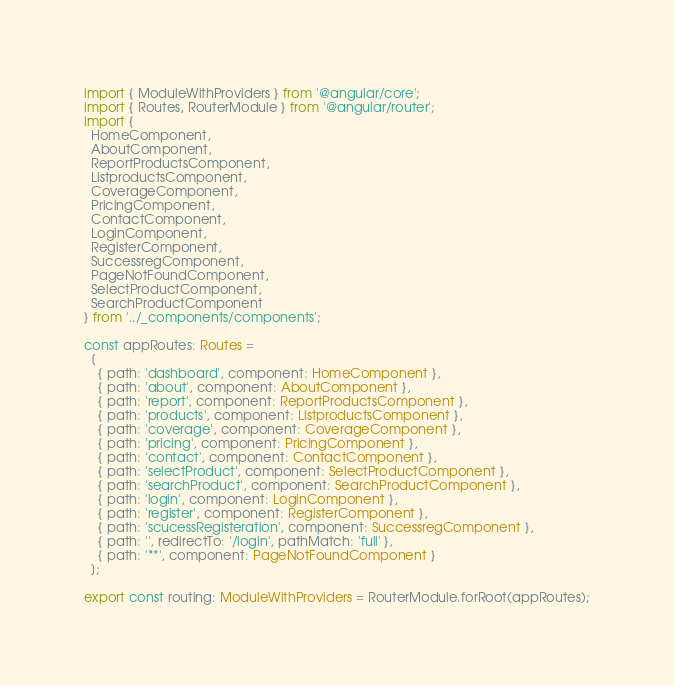<code> <loc_0><loc_0><loc_500><loc_500><_TypeScript_>import { ModuleWithProviders } from '@angular/core';
import { Routes, RouterModule } from '@angular/router';
import {
  HomeComponent,
  AboutComponent,
  ReportProductsComponent,
  ListproductsComponent,
  CoverageComponent,
  PricingComponent,
  ContactComponent,
  LoginComponent,
  RegisterComponent,
  SuccessregComponent,
  PageNotFoundComponent,
  SelectProductComponent,
  SearchProductComponent
} from '../_components/components';

const appRoutes: Routes =
  [
    { path: 'dashboard', component: HomeComponent },
    { path: 'about', component: AboutComponent },
    { path: 'report', component: ReportProductsComponent },
    { path: 'products', component: ListproductsComponent },
    { path: 'coverage', component: CoverageComponent },
    { path: 'pricing', component: PricingComponent },
    { path: 'contact', component: ContactComponent },
    { path: 'selectProduct', component: SelectProductComponent },    
    { path: 'searchProduct', component: SearchProductComponent },
    { path: 'login', component: LoginComponent },
    { path: 'register', component: RegisterComponent },    
    { path: 'scucessRegisteration', component: SuccessregComponent },
    { path: '', redirectTo: '/login', pathMatch: 'full' },
    { path: '**', component: PageNotFoundComponent }
  ];

export const routing: ModuleWithProviders = RouterModule.forRoot(appRoutes);
</code> 